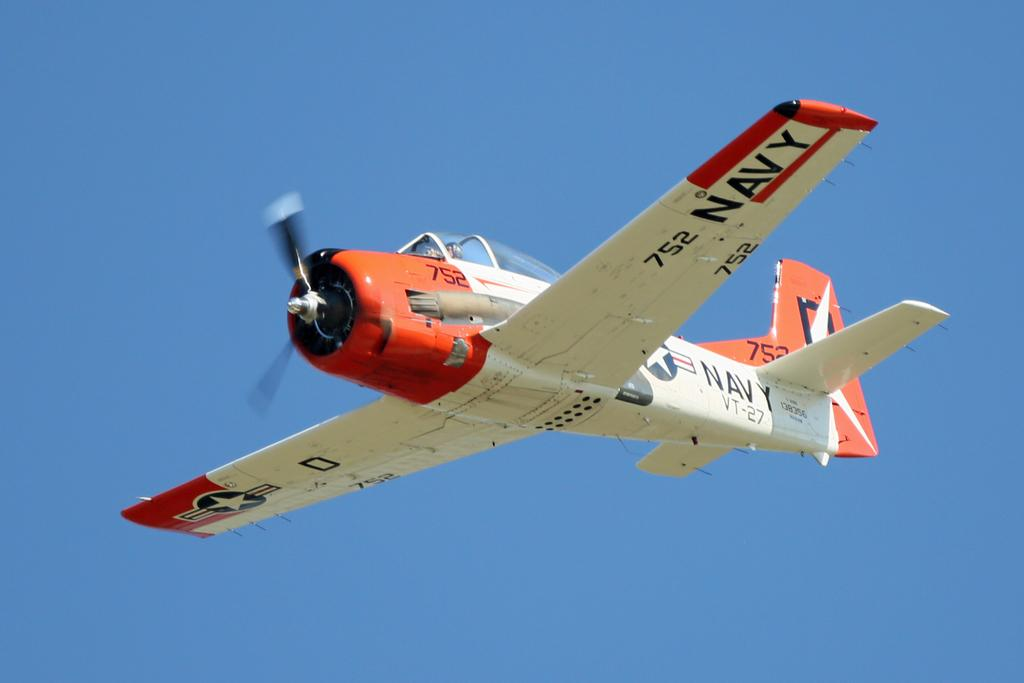<image>
Share a concise interpretation of the image provided. A red and white plane with the word navy on its wing also has a star on it. 